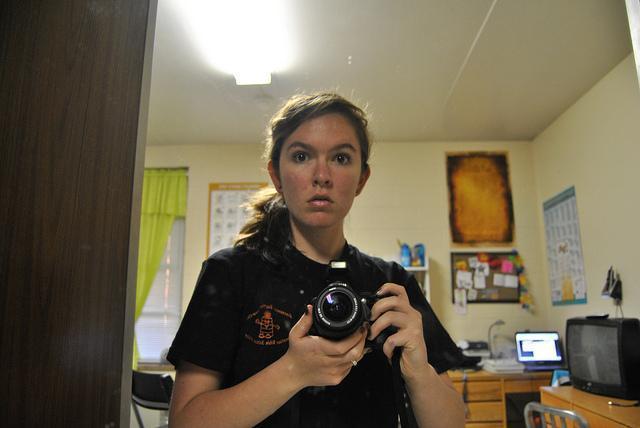How many toothbrushes are shown?
Give a very brief answer. 0. 